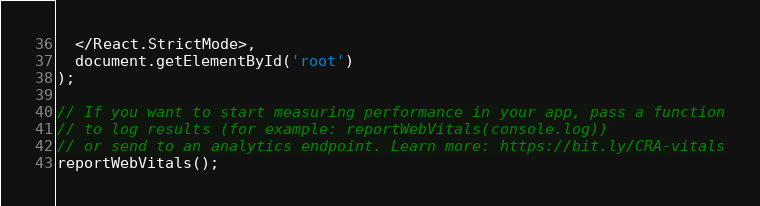Convert code to text. <code><loc_0><loc_0><loc_500><loc_500><_JavaScript_>  </React.StrictMode>,
  document.getElementById('root')
);

// If you want to start measuring performance in your app, pass a function
// to log results (for example: reportWebVitals(console.log))
// or send to an analytics endpoint. Learn more: https://bit.ly/CRA-vitals
reportWebVitals();
</code> 